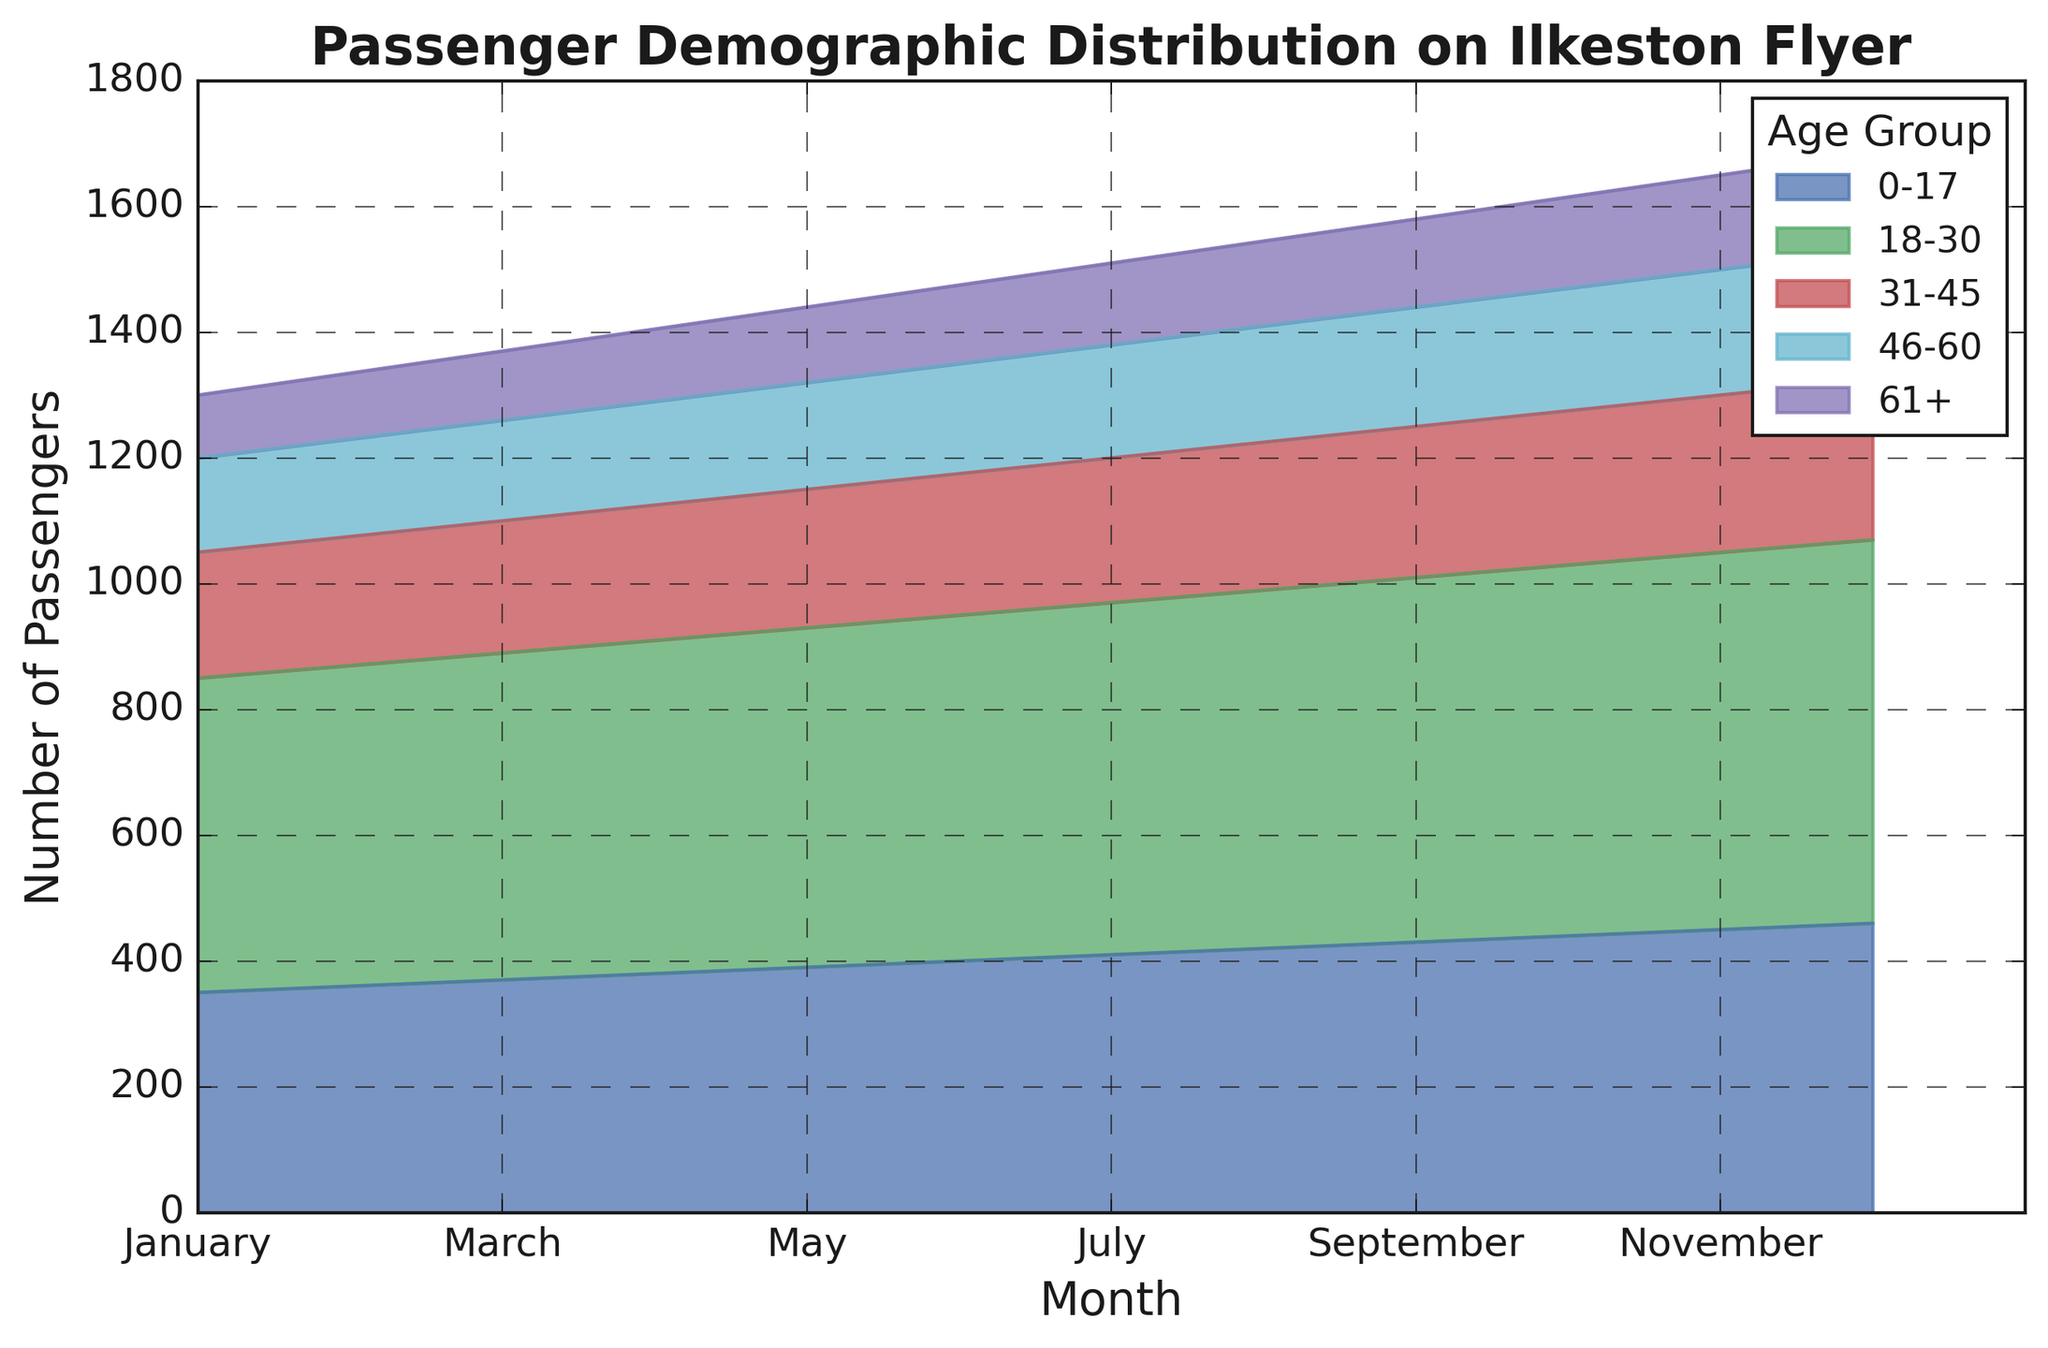Why is there a gradual increase in passengers in each age group from January to December? From January to December, there is a consistent rise in the number of passengers across all age groups, indicating either a growth in the popularity of the Ilkeston Flyer or seasonal variations that affect all demographics similarly. For instance, the number of passengers aged 0-17 increases steadily from 350 in January to 460 in December.
Answer: A growing trend in usage Which age group has the highest number of passengers in December? By looking at the area chart, it is evident that the age group 18-30 has consistently large areas, and in December, this group continues to have the highest number of passengers, with a count of 610.
Answer: 18-30 Out of the 31-45 and 46-60 age groups, which one shows a higher increase in passengers from June to December? From June to December, the number of passengers in the 31-45 age group increases from 225 to 255, an increase of 30 passengers. For the 46-60 age group, the number of passengers increases from 175 to 205, an increase of 30 passengers. Both groups have the same increase.
Answer: Both increased by 30 Which month shows the highest total number of passengers across all age groups? To find the month with the highest total number of passengers, one would sum the passenger counts for all age groups in each month. December has the highest individual counts across all groups which, when summed, yields the highest total.
Answer: December How does the number of passengers in the 0-17 age group in April compare to the 31-45 age group in the same month? In April, the number of passengers in the 0-17 age group is 380, while the number for the 31-45 age group is 215, making the count in the 0-17 age group much higher.
Answer: 0-17 higher than 31-45 What is the total number of passengers aged 61+ across the entire year? To get the total number of passengers aged 61+ for the entire year, add the passenger counts for each month: 100 + 105 + 110 + 115 + 120 + 125 + 130 + 135 + 140 + 145 + 150 + 155 = 1530.
Answer: 1530 Calculate the difference in the number of passengers between the 18-30 and 46-60 age groups in October. In October, the number of passengers in the 18-30 age group is 590, and for the 46-60 age group, it is 195. The difference is 590 - 195 = 395.
Answer: 395 Which age group has the most stable (least fluctuating) number of passengers over the year? By observing the area chart, the 61+ age group shows the smallest incremental changes across months, indicating the most stable number of passengers over the year.
Answer: 61+ During which month do all age groups collectively have the least number of passengers? Summing up passenger counts for each month, January shows the least total number of passengers across all age groups.
Answer: January 